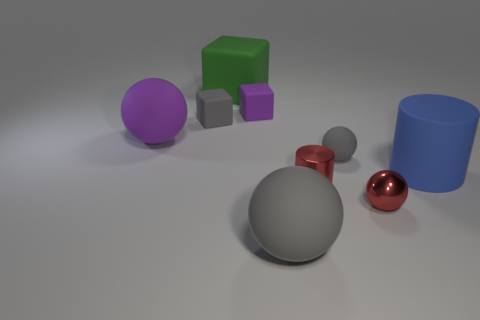Is the number of tiny gray rubber blocks to the left of the large block greater than the number of big green rubber things that are to the right of the blue matte thing?
Your answer should be very brief. Yes. There is a big blue thing that is in front of the large green object; what is it made of?
Offer a very short reply. Rubber. Is the large gray object the same shape as the blue thing?
Provide a short and direct response. No. Is there anything else that is the same color as the large matte cylinder?
Your answer should be compact. No. The other shiny object that is the same shape as the big gray thing is what color?
Offer a terse response. Red. Are there more purple matte objects right of the tiny gray rubber block than large green matte blocks?
Offer a very short reply. No. There is a matte thing that is in front of the tiny red sphere; what color is it?
Your answer should be compact. Gray. Is the blue rubber thing the same size as the purple sphere?
Keep it short and to the point. Yes. What size is the green rubber object?
Ensure brevity in your answer.  Large. What is the shape of the tiny shiny object that is the same color as the metallic cylinder?
Your answer should be compact. Sphere. 